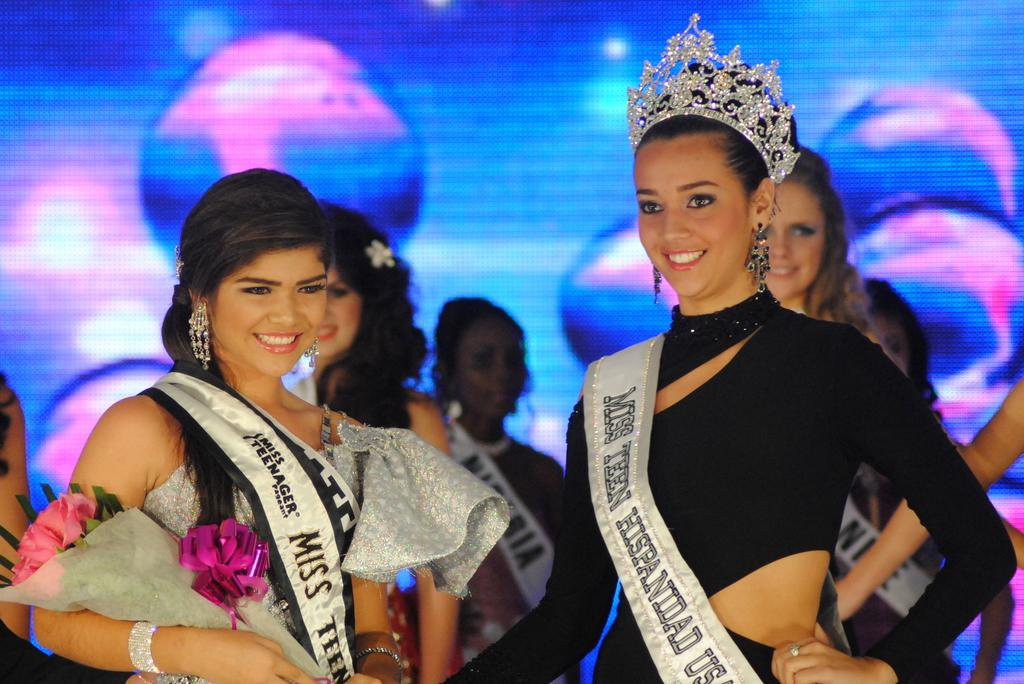<image>
Relay a brief, clear account of the picture shown. Several women stand on stage wearing sashes for Miss Teen Hispanidad USA, one of them also wearing a crown. 